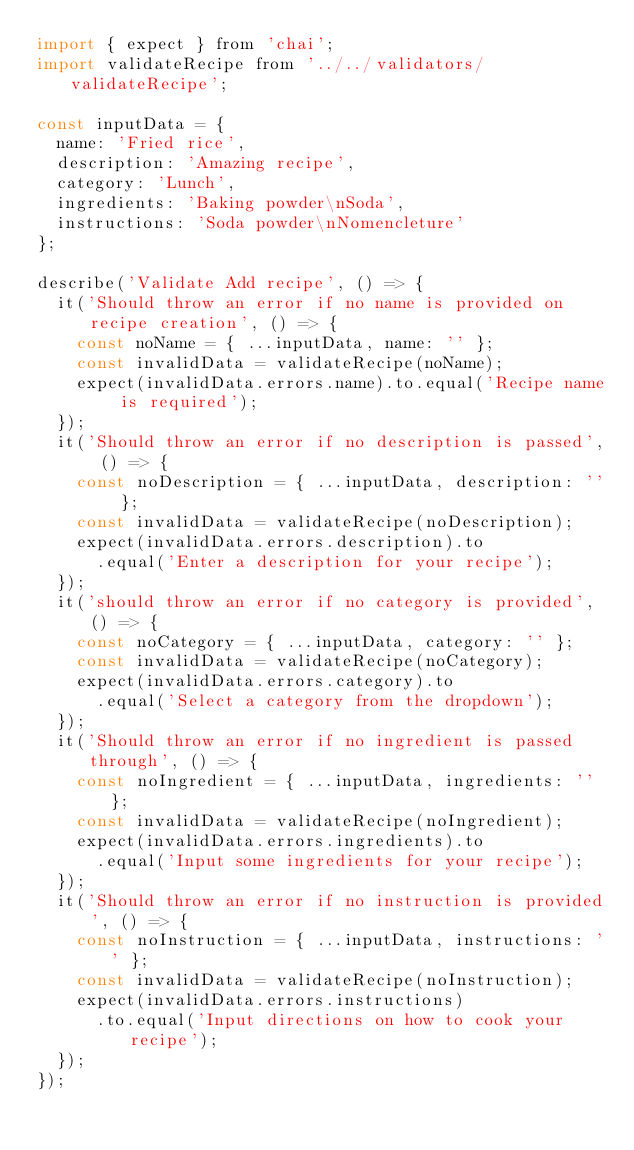<code> <loc_0><loc_0><loc_500><loc_500><_JavaScript_>import { expect } from 'chai';
import validateRecipe from '../../validators/validateRecipe';

const inputData = {
  name: 'Fried rice',
  description: 'Amazing recipe',
  category: 'Lunch',
  ingredients: 'Baking powder\nSoda',
  instructions: 'Soda powder\nNomencleture'
};

describe('Validate Add recipe', () => {
  it('Should throw an error if no name is provided on recipe creation', () => {
    const noName = { ...inputData, name: '' };
    const invalidData = validateRecipe(noName);
    expect(invalidData.errors.name).to.equal('Recipe name is required');
  });
  it('Should throw an error if no description is passed', () => {
    const noDescription = { ...inputData, description: '' };
    const invalidData = validateRecipe(noDescription);
    expect(invalidData.errors.description).to
      .equal('Enter a description for your recipe');
  });
  it('should throw an error if no category is provided', () => {
    const noCategory = { ...inputData, category: '' };
    const invalidData = validateRecipe(noCategory);
    expect(invalidData.errors.category).to
      .equal('Select a category from the dropdown');
  });
  it('Should throw an error if no ingredient is passed through', () => {
    const noIngredient = { ...inputData, ingredients: '' };
    const invalidData = validateRecipe(noIngredient);
    expect(invalidData.errors.ingredients).to
      .equal('Input some ingredients for your recipe');
  });
  it('Should throw an error if no instruction is provided', () => {
    const noInstruction = { ...inputData, instructions: '' };
    const invalidData = validateRecipe(noInstruction);
    expect(invalidData.errors.instructions)
      .to.equal('Input directions on how to cook your recipe');
  });
});
</code> 